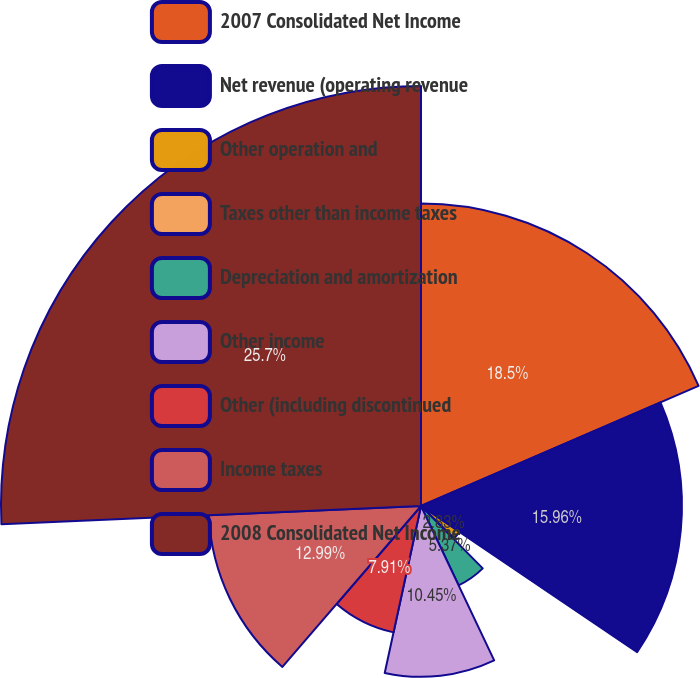Convert chart. <chart><loc_0><loc_0><loc_500><loc_500><pie_chart><fcel>2007 Consolidated Net Income<fcel>Net revenue (operating revenue<fcel>Other operation and<fcel>Taxes other than income taxes<fcel>Depreciation and amortization<fcel>Other income<fcel>Other (including discontinued<fcel>Income taxes<fcel>2008 Consolidated Net Income<nl><fcel>18.5%<fcel>15.96%<fcel>2.83%<fcel>0.29%<fcel>5.37%<fcel>10.45%<fcel>7.91%<fcel>12.99%<fcel>25.69%<nl></chart> 